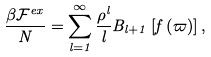Convert formula to latex. <formula><loc_0><loc_0><loc_500><loc_500>\frac { \beta \mathcal { F } ^ { e x } } { N } = \sum ^ { \infty } _ { l = 1 } \frac { \rho ^ { l } } { l } B _ { l + 1 } \left [ f \left ( \varpi \right ) \right ] ,</formula> 